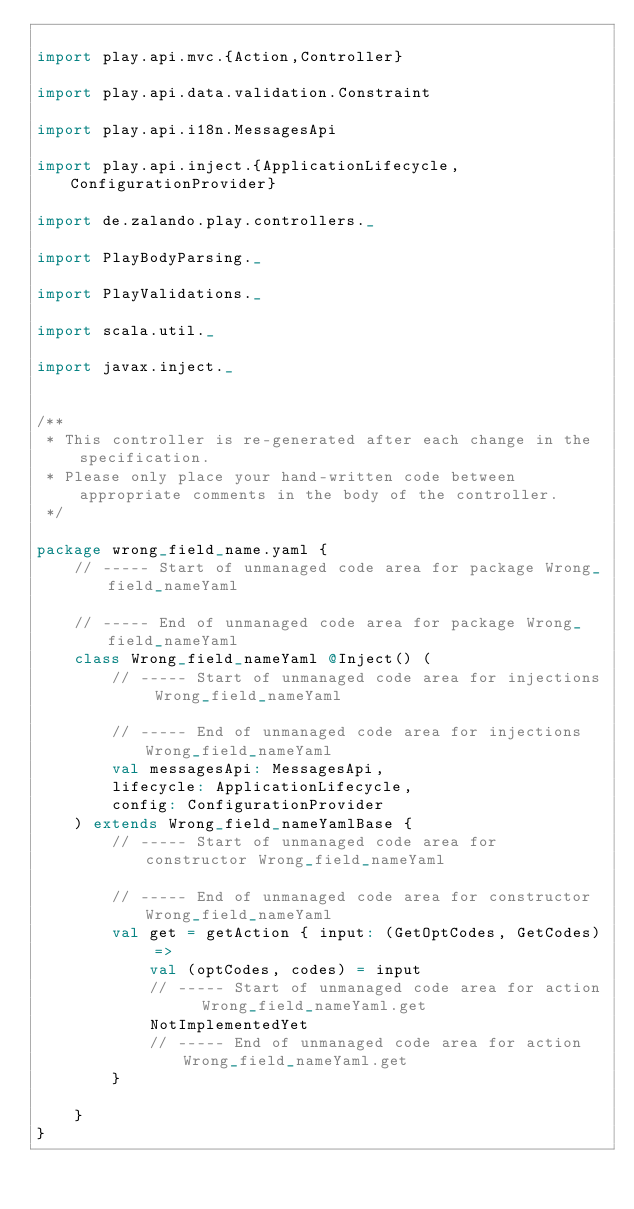<code> <loc_0><loc_0><loc_500><loc_500><_Scala_>
import play.api.mvc.{Action,Controller}

import play.api.data.validation.Constraint

import play.api.i18n.MessagesApi

import play.api.inject.{ApplicationLifecycle,ConfigurationProvider}

import de.zalando.play.controllers._

import PlayBodyParsing._

import PlayValidations._

import scala.util._

import javax.inject._


/**
 * This controller is re-generated after each change in the specification.
 * Please only place your hand-written code between appropriate comments in the body of the controller.
 */

package wrong_field_name.yaml {
    // ----- Start of unmanaged code area for package Wrong_field_nameYaml
            
    // ----- End of unmanaged code area for package Wrong_field_nameYaml
    class Wrong_field_nameYaml @Inject() (
        // ----- Start of unmanaged code area for injections Wrong_field_nameYaml

        // ----- End of unmanaged code area for injections Wrong_field_nameYaml
        val messagesApi: MessagesApi,
        lifecycle: ApplicationLifecycle,
        config: ConfigurationProvider
    ) extends Wrong_field_nameYamlBase {
        // ----- Start of unmanaged code area for constructor Wrong_field_nameYaml

        // ----- End of unmanaged code area for constructor Wrong_field_nameYaml
        val get = getAction { input: (GetOptCodes, GetCodes) =>
            val (optCodes, codes) = input
            // ----- Start of unmanaged code area for action  Wrong_field_nameYaml.get
            NotImplementedYet
            // ----- End of unmanaged code area for action  Wrong_field_nameYaml.get
        }
    
    }
}
</code> 